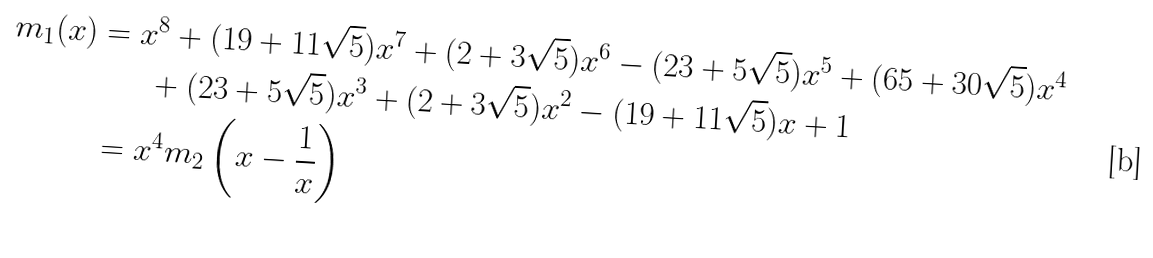<formula> <loc_0><loc_0><loc_500><loc_500>m _ { 1 } ( x ) & = x ^ { 8 } + ( 1 9 + 1 1 \sqrt { 5 } ) x ^ { 7 } + ( 2 + 3 \sqrt { 5 } ) x ^ { 6 } - ( 2 3 + 5 \sqrt { 5 } ) x ^ { 5 } + ( 6 5 + 3 0 \sqrt { 5 } ) x ^ { 4 } \\ & \quad \ \ + ( 2 3 + 5 \sqrt { 5 } ) x ^ { 3 } + ( 2 + 3 \sqrt { 5 } ) x ^ { 2 } - ( 1 9 + 1 1 \sqrt { 5 } ) x + 1 \\ & = x ^ { 4 } m _ { 2 } \left ( x - \frac { 1 } { x } \right )</formula> 